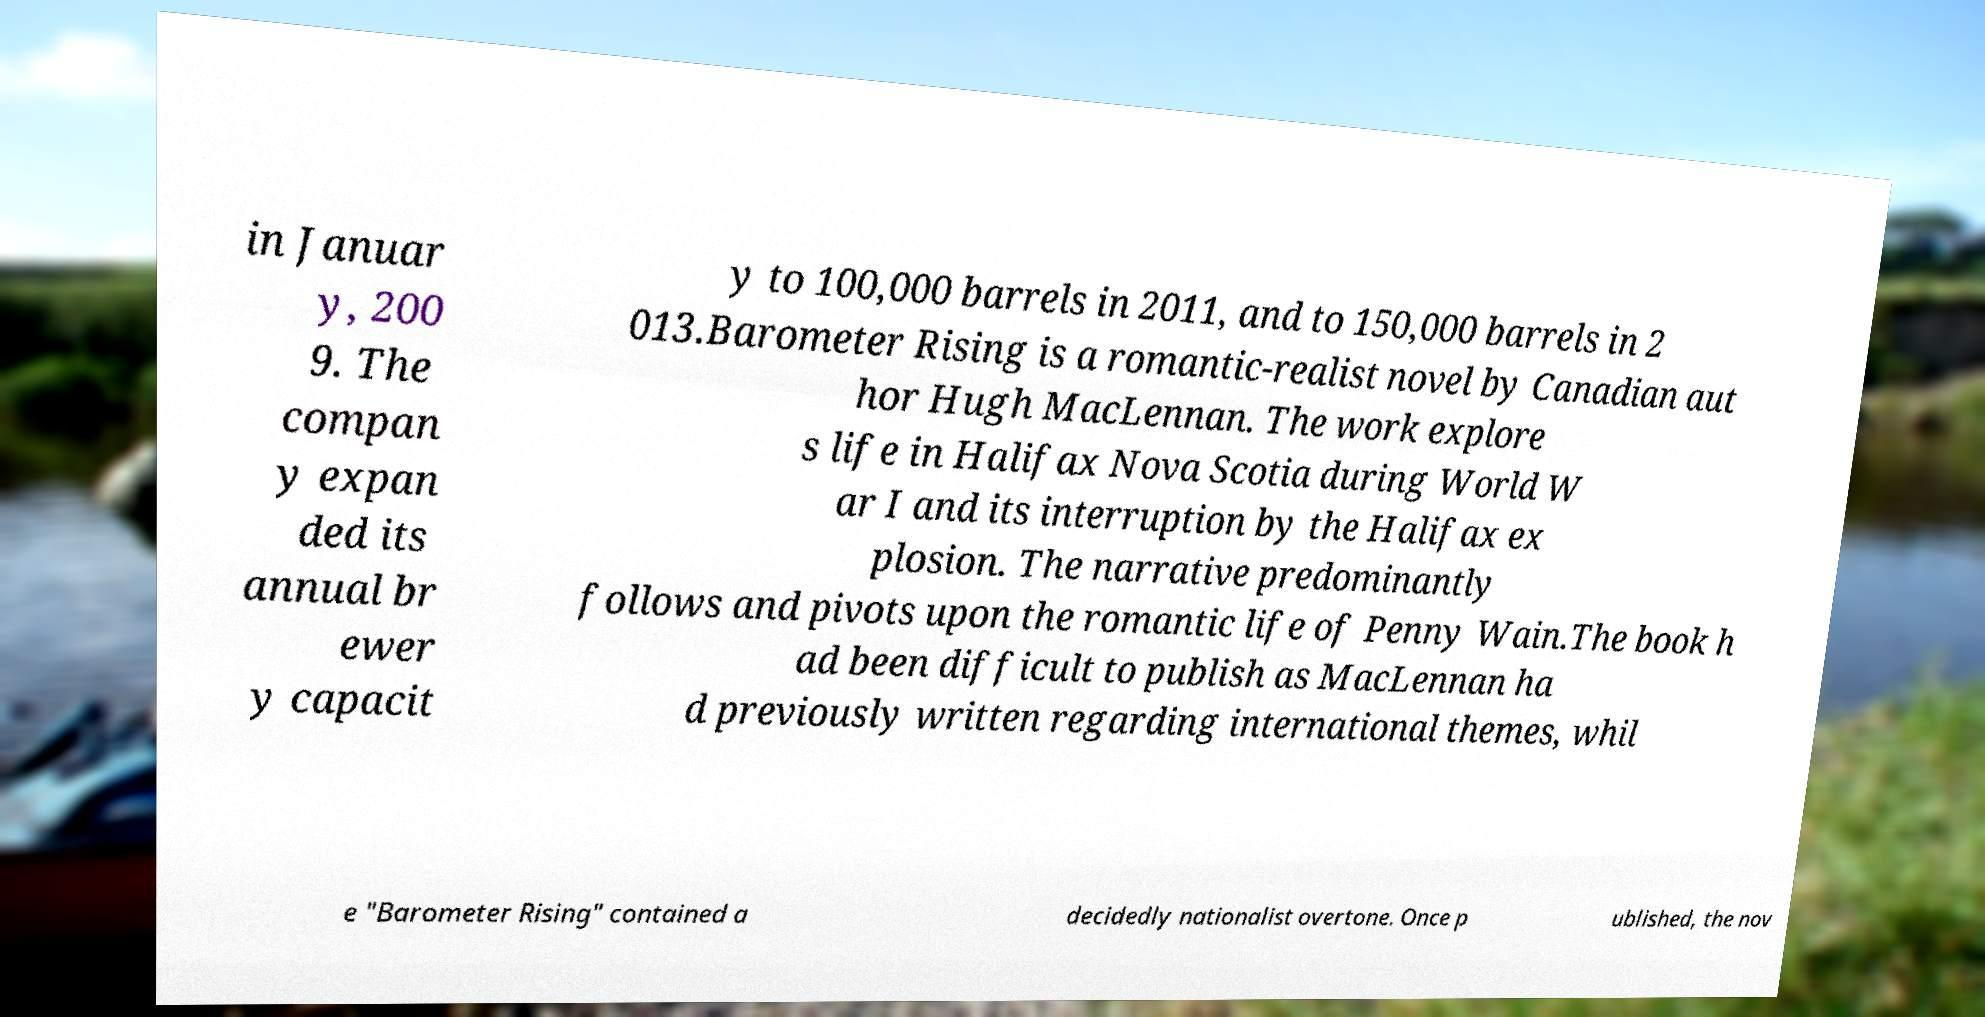Can you accurately transcribe the text from the provided image for me? in Januar y, 200 9. The compan y expan ded its annual br ewer y capacit y to 100,000 barrels in 2011, and to 150,000 barrels in 2 013.Barometer Rising is a romantic-realist novel by Canadian aut hor Hugh MacLennan. The work explore s life in Halifax Nova Scotia during World W ar I and its interruption by the Halifax ex plosion. The narrative predominantly follows and pivots upon the romantic life of Penny Wain.The book h ad been difficult to publish as MacLennan ha d previously written regarding international themes, whil e "Barometer Rising" contained a decidedly nationalist overtone. Once p ublished, the nov 